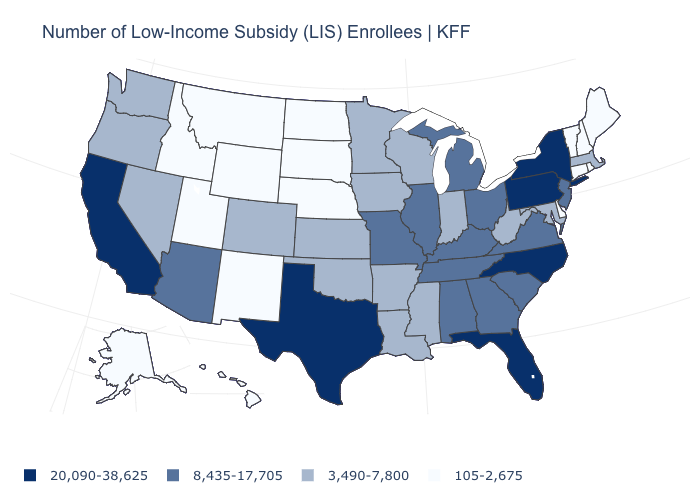Name the states that have a value in the range 3,490-7,800?
Quick response, please. Arkansas, Colorado, Indiana, Iowa, Kansas, Louisiana, Maryland, Massachusetts, Minnesota, Mississippi, Nevada, Oklahoma, Oregon, Washington, West Virginia, Wisconsin. Is the legend a continuous bar?
Be succinct. No. Name the states that have a value in the range 8,435-17,705?
Concise answer only. Alabama, Arizona, Georgia, Illinois, Kentucky, Michigan, Missouri, New Jersey, Ohio, South Carolina, Tennessee, Virginia. How many symbols are there in the legend?
Be succinct. 4. How many symbols are there in the legend?
Quick response, please. 4. Does New York have the same value as Oklahoma?
Write a very short answer. No. What is the highest value in the West ?
Short answer required. 20,090-38,625. Which states have the lowest value in the West?
Concise answer only. Alaska, Hawaii, Idaho, Montana, New Mexico, Utah, Wyoming. Does the first symbol in the legend represent the smallest category?
Quick response, please. No. Does New York have the same value as North Carolina?
Short answer required. Yes. Which states have the highest value in the USA?
Concise answer only. California, Florida, New York, North Carolina, Pennsylvania, Texas. What is the value of Connecticut?
Be succinct. 105-2,675. Name the states that have a value in the range 20,090-38,625?
Answer briefly. California, Florida, New York, North Carolina, Pennsylvania, Texas. How many symbols are there in the legend?
Answer briefly. 4. What is the value of Ohio?
Short answer required. 8,435-17,705. 